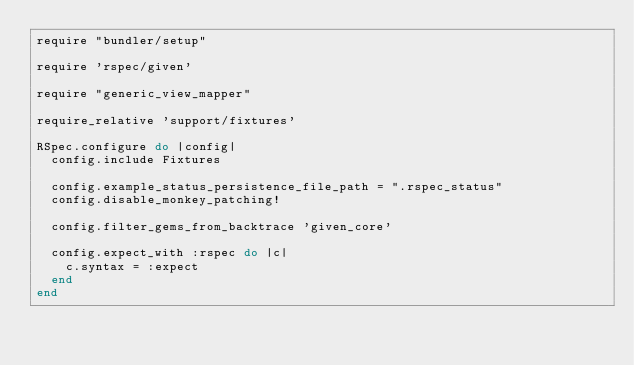Convert code to text. <code><loc_0><loc_0><loc_500><loc_500><_Ruby_>require "bundler/setup"

require 'rspec/given'

require "generic_view_mapper"

require_relative 'support/fixtures'

RSpec.configure do |config|
  config.include Fixtures

  config.example_status_persistence_file_path = ".rspec_status"
  config.disable_monkey_patching!

  config.filter_gems_from_backtrace 'given_core'

  config.expect_with :rspec do |c|
    c.syntax = :expect
  end
end
</code> 